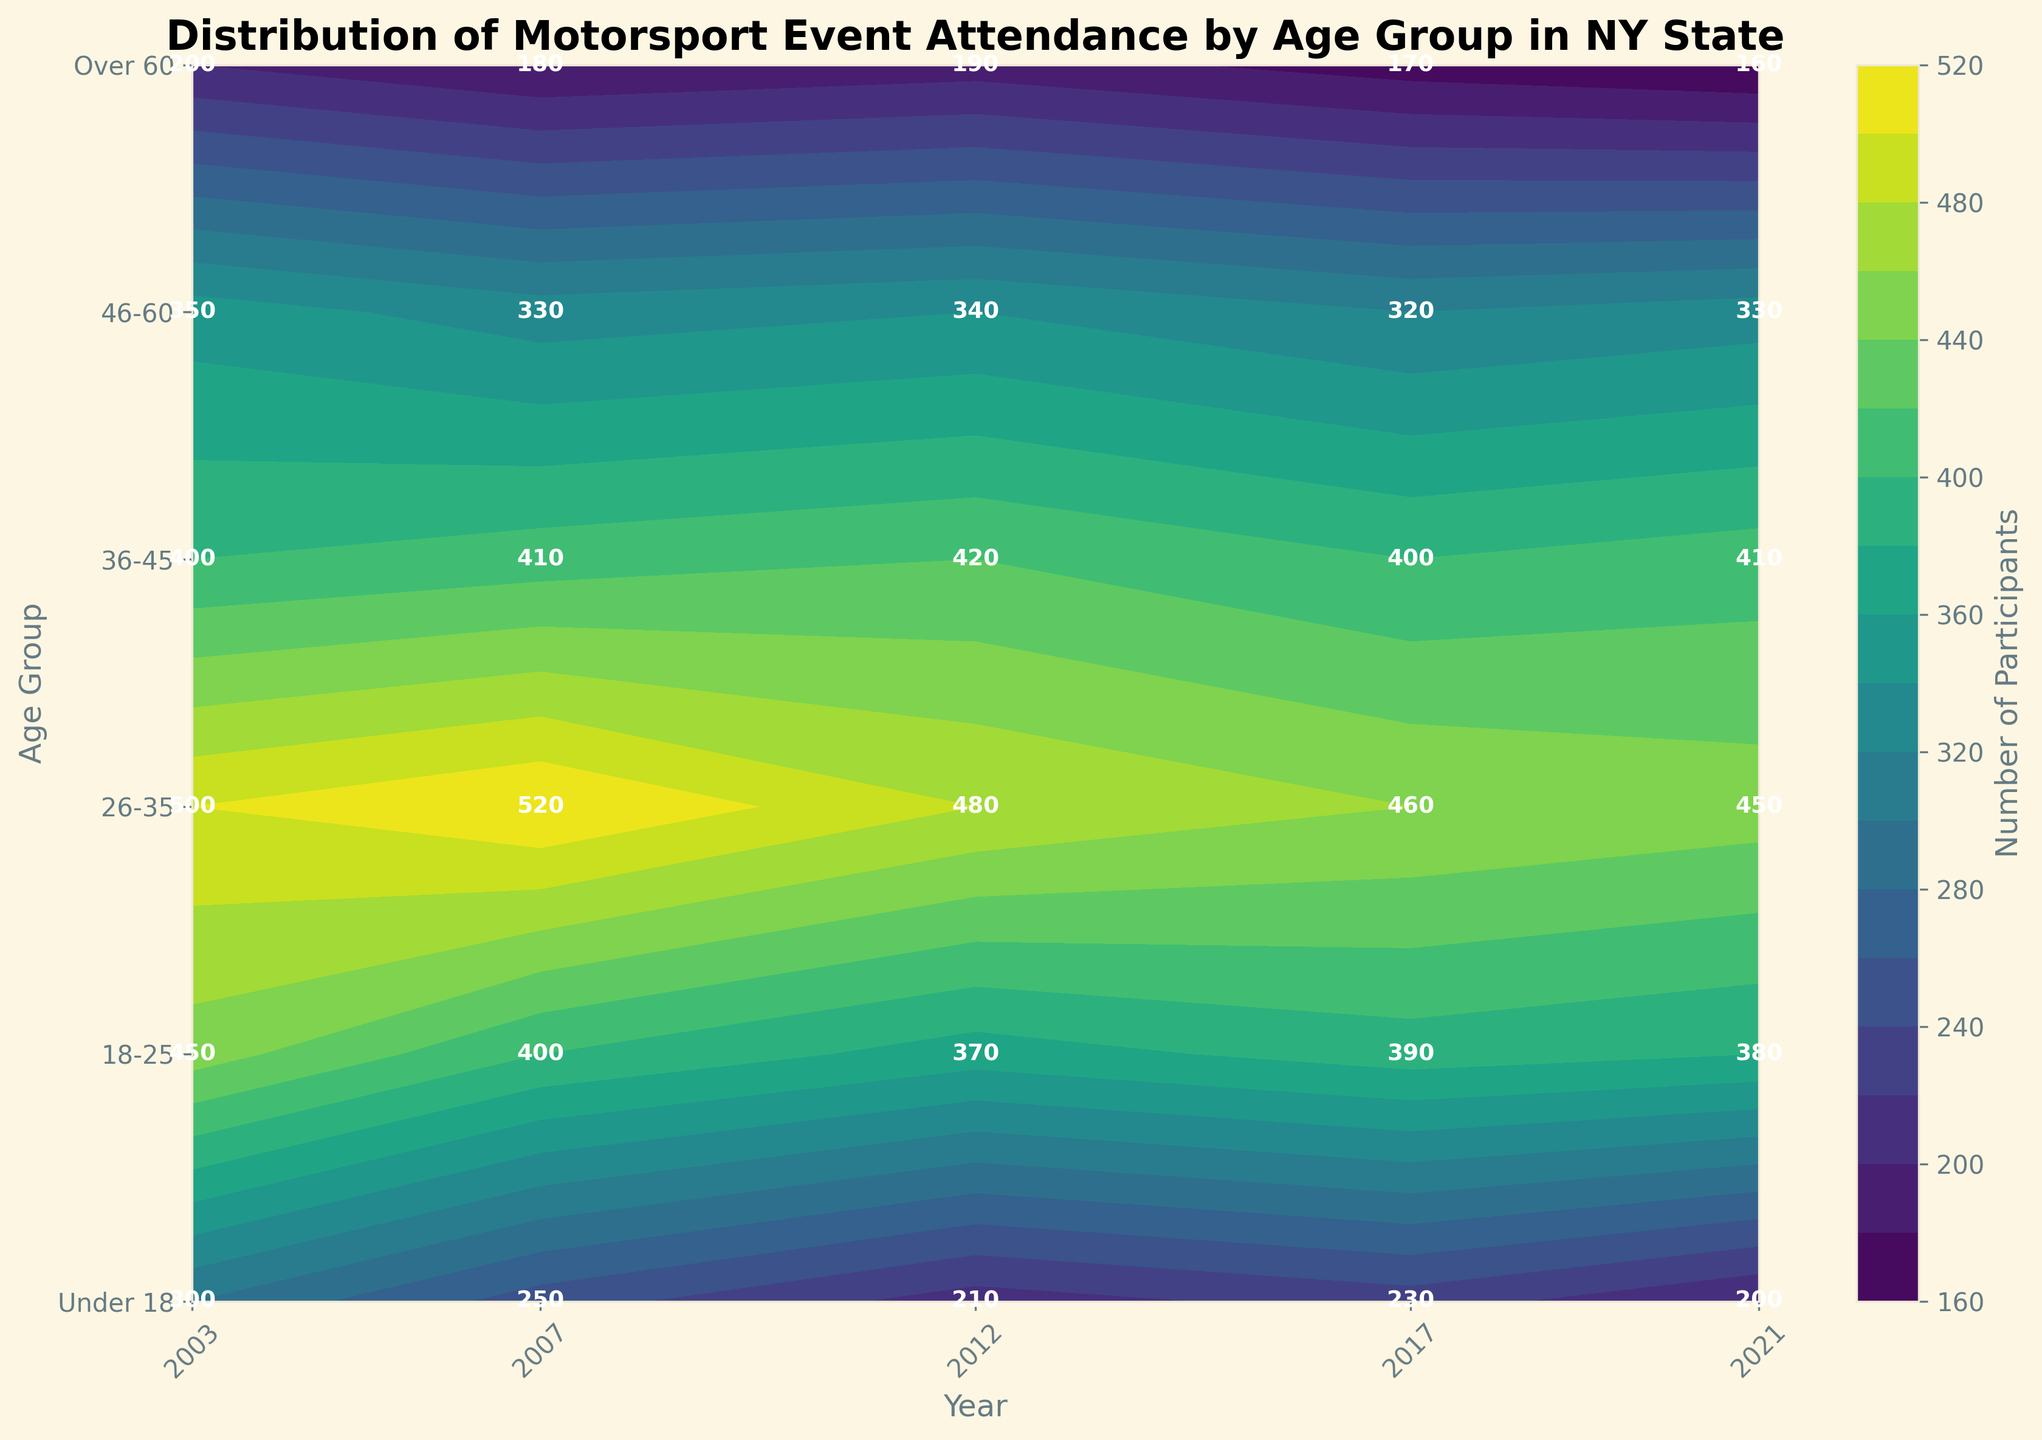what is the title of the plot? The title is located at the top of the plot in large, bold font. It concisely summarizes the content of the figure for easy identification.
Answer: Distribution of Motorsport Event Attendance by Age Group in NY State Which age group had the highest participation in 2003? Locate the vertical section of the plot corresponding to the year 2003. Then, identify the age group having the highest intensity of color or the highest annotated number.
Answer: 26-35 What was the total number of participants across all age groups in 2012? Check the values corresponding to the year 2012 for each age group. Sum these values to get the total number of participants. The values are: 210 + 370 + 480 + 420 + 340 + 190. 210 + 370 + 480 + 420 + 340 + 190 = 2010.
Answer: 2010 How did participant numbers for the age group 18-25 change from 2007 to 2021? Locate the values for age group 18-25 in the years 2007 and 2021. Calculate the difference between the two numbers. The values are: 400 in 2007 and 380 in 2021. 400 - 380 = 20.
Answer: Decreased by 20 In which year did the Under 18 age group see the lowest participation? Compare the participation values for the Under 18 age group across all years. Identify the year with the lowest value. The values are: 300, 250, 210, 230, 200.
Answer: 2021 What is the trend in participation for the Over 60 age group from 2003 to 2021? Observe the values for the Over 60 age group over the years 2003, 2007, 2012, 2017, and 2021. Analyze if the numbers are increasing, decreasing, or stable. The values are: 200, 180, 190, 170, 160.
Answer: Decreasing Which age group had the most consistent participant numbers over the years? Examine the participation numbers for each age group across all years, identifying the age group with the least variation in numbers.
Answer: 36-45 What is the average number of participants for the 46-60 age group over the 20 years? Sum the participant numbers for the 46-60 age group across all years and divide by the number of years. The values are: 350, 330, 340, 320, 330. (350 + 330 + 340 + 320 + 330) / 5 = 334
Answer: 334 